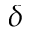<formula> <loc_0><loc_0><loc_500><loc_500>\delta</formula> 